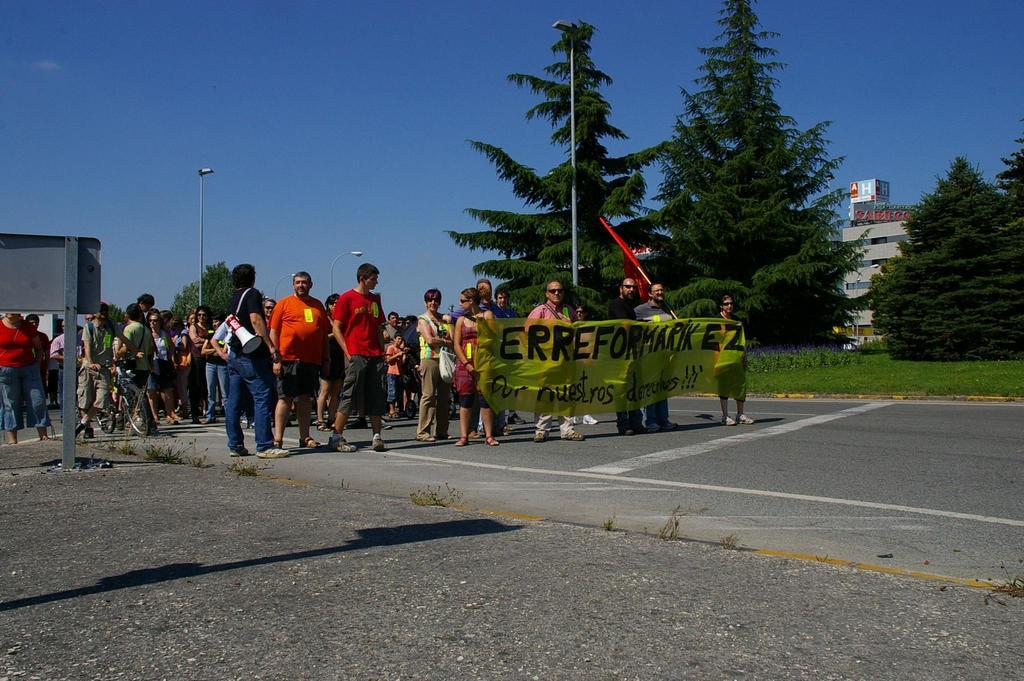<image>
Offer a succinct explanation of the picture presented. A group of people hold a yellow sign that reads, "ERREFORKMARIK EZ 